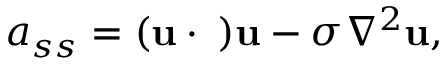Convert formula to latex. <formula><loc_0><loc_0><loc_500><loc_500>a _ { s s } = ( { u } \cdot { \nabla } ) { u } - \sigma \nabla ^ { 2 } { u } ,</formula> 